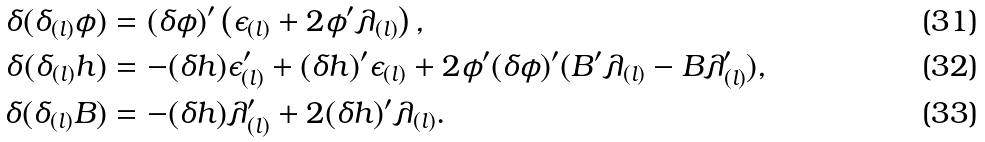<formula> <loc_0><loc_0><loc_500><loc_500>\delta ( \delta _ { ( l ) } \phi ) & = ( \delta \phi ) ^ { \prime } \left ( \epsilon _ { ( l ) } + 2 \phi ^ { \prime } \lambda _ { ( l ) } \right ) , \\ \delta ( \delta _ { ( l ) } h ) & = - ( \delta h ) \epsilon _ { ( l ) } ^ { \prime } + ( \delta h ) ^ { \prime } \epsilon _ { ( l ) } + 2 \phi ^ { \prime } ( \delta \phi ) ^ { \prime } ( B ^ { \prime } \lambda _ { ( l ) } - B \lambda _ { ( l ) } ^ { \prime } ) , \\ \delta ( \delta _ { ( l ) } B ) & = - ( \delta h ) \lambda _ { ( l ) } ^ { \prime } + 2 ( \delta h ) ^ { \prime } \lambda _ { ( l ) } .</formula> 